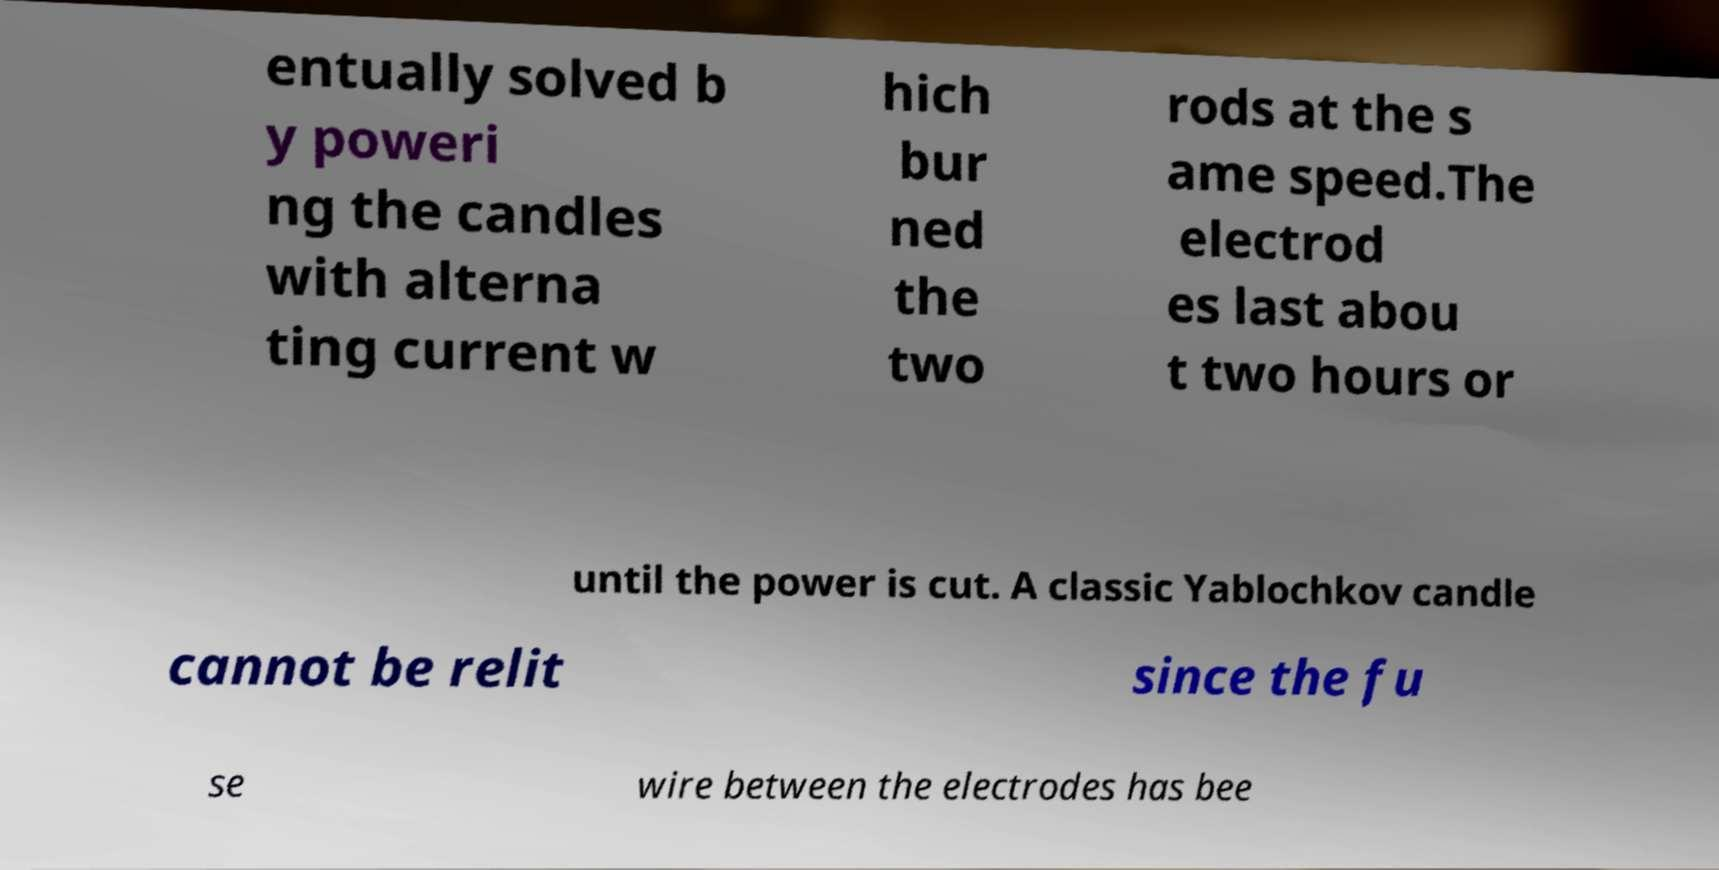What messages or text are displayed in this image? I need them in a readable, typed format. entually solved b y poweri ng the candles with alterna ting current w hich bur ned the two rods at the s ame speed.The electrod es last abou t two hours or until the power is cut. A classic Yablochkov candle cannot be relit since the fu se wire between the electrodes has bee 